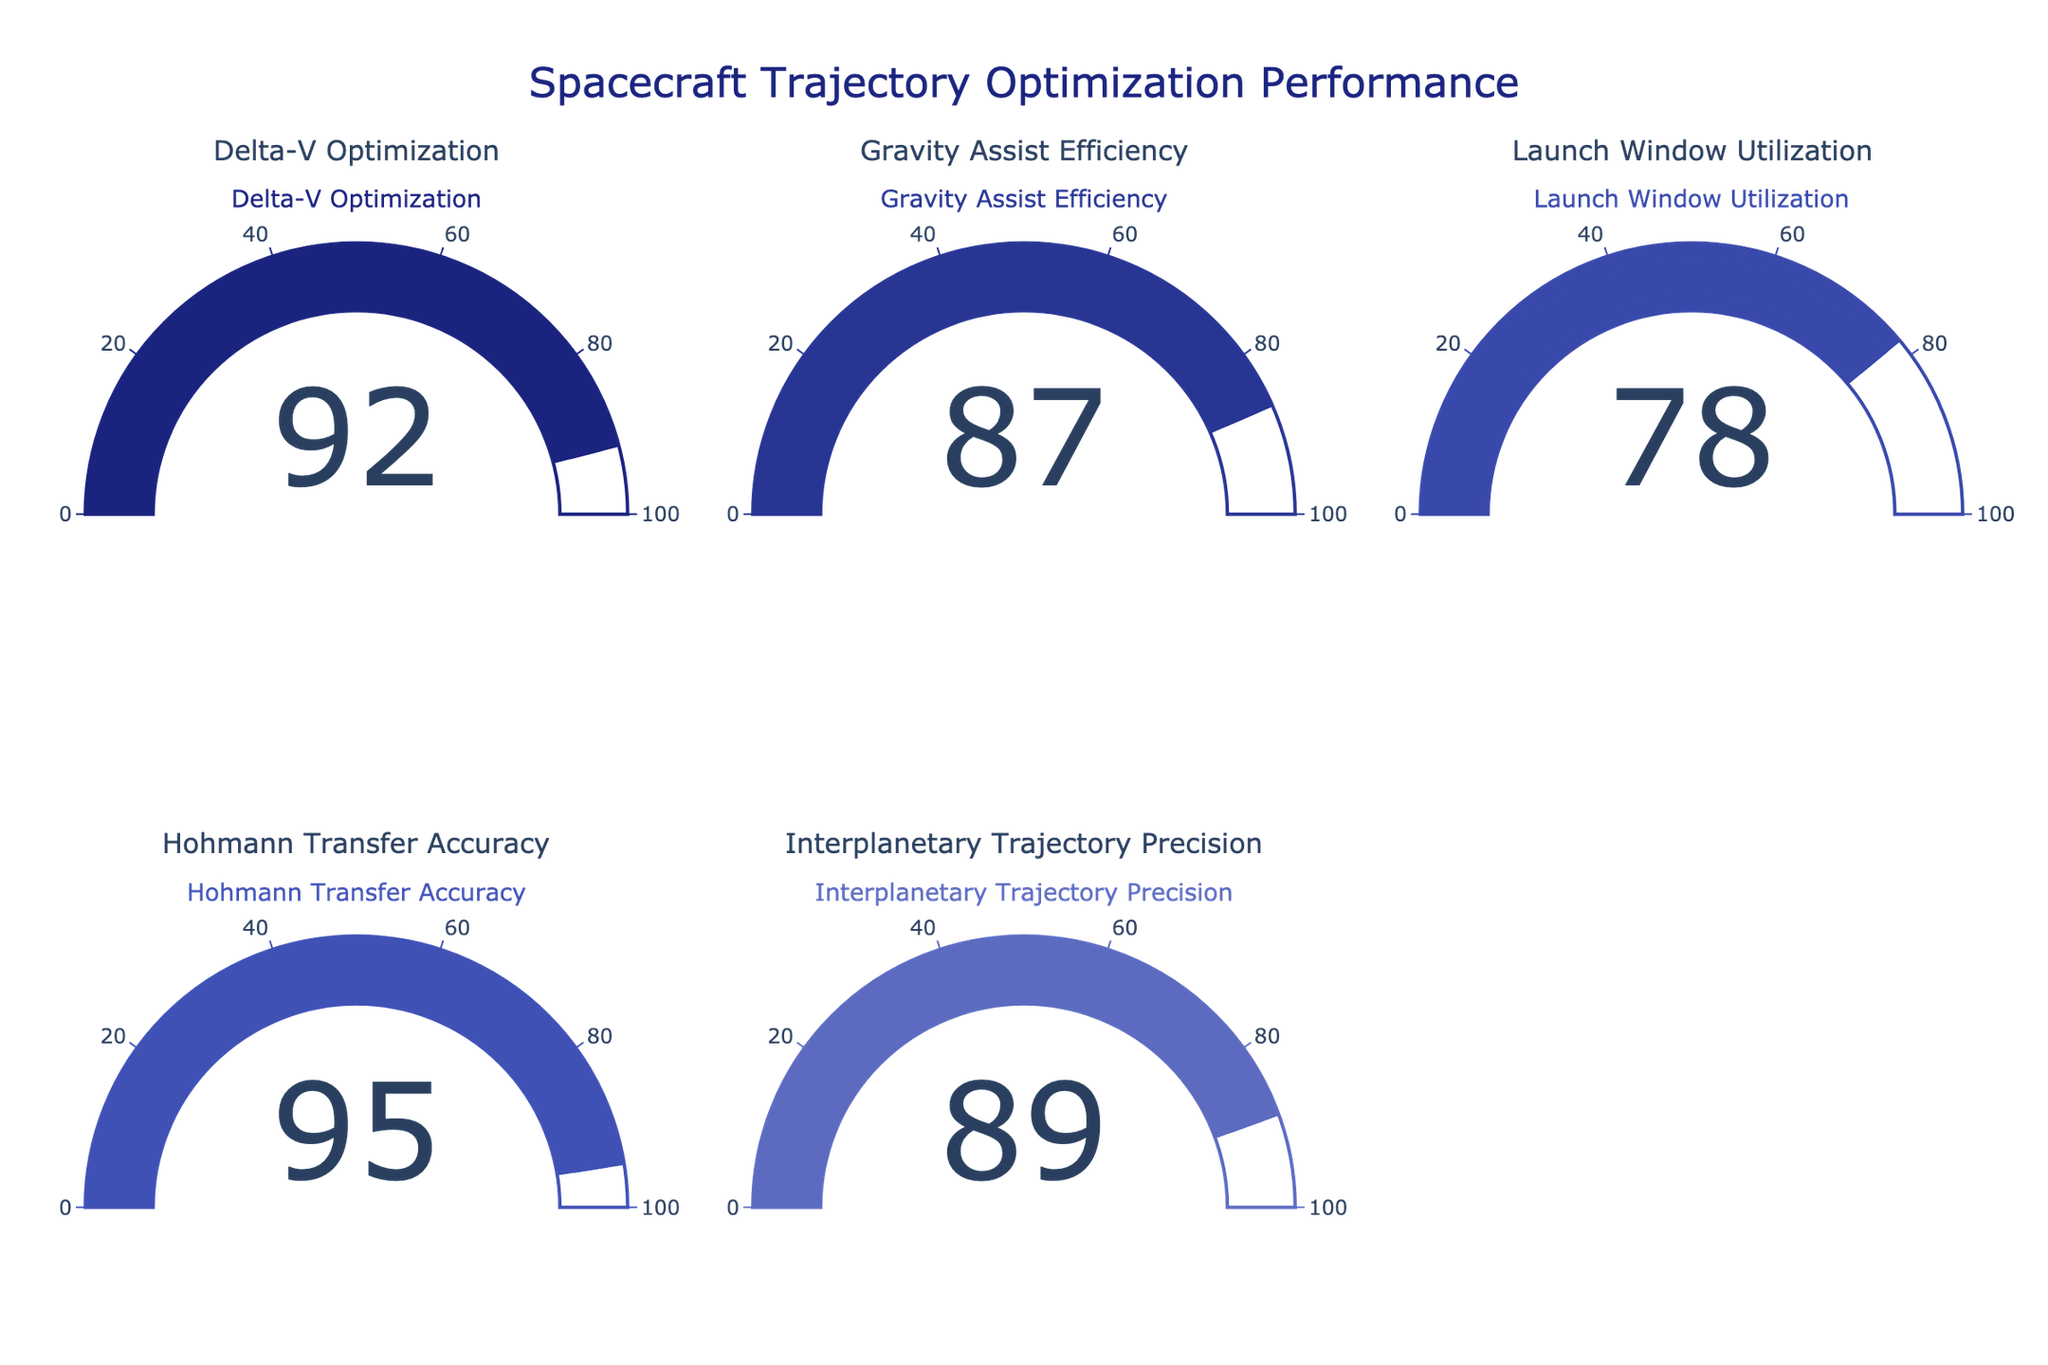Which mission has the highest performance? Identify the gauge with the highest value displayed. The "Hohmann Transfer Accuracy" shows a performance value of 95, which is the highest.
Answer: Hohmann Transfer Accuracy What is the title of the figure? Look at the central or top part of the figure to find the title. The title reads "Spacecraft Trajectory Optimization Performance."
Answer: Spacecraft Trajectory Optimization Performance How many missions are depicted in the figure? Count the number of unique gauges. There are 5 gauges, each corresponding to a different mission.
Answer: 5 Which mission has the lowest performance? Identify the gauge with the smallest value displayed. The "Launch Window Utilization" shows the lowest value at 78.
Answer: Launch Window Utilization What is the combined performance value of "Delta-V Optimization" and "Gravity Assist Efficiency"? Sum the values of these two missions. "Delta-V Optimization" is 92 and "Gravity Assist Efficiency" is 87. Their sum is 92 + 87 = 179.
Answer: 179 How much higher is the performance of "Hohmann Transfer Accuracy" compared to "Interplanetary Trajectory Precision"? Subtract the value of "Interplanetary Trajectory Precision" from "Hohmann Transfer Accuracy." Hohmann Transfer Accuracy is 95, and Interplanetary Trajectory Precision is 89. So, 95 - 89 = 6.
Answer: 6 Which missions have a performance value greater than 85? Identify the gauges with values higher than 85. These are "Delta-V Optimization" (92), "Gravity Assist Efficiency" (87), "Hohmann Transfer Accuracy" (95), and "Interplanetary Trajectory Precision" (89).
Answer: Delta-V Optimization, Gravity Assist Efficiency, Hohmann Transfer Accuracy, Interplanetary Trajectory Precision What is the average performance value of all the missions? Add all the performance values and divide by the number of missions. The values are 92, 87, 78, 95, and 89. Their sum is 92 + 87 + 78 + 95 + 89 = 441. Dividing by 5, the average is 441 / 5 = 88.2.
Answer: 88.2 What is the color of the gauge bar for "Interplanetary Trajectory Precision"? Look at the color of the "Interplanetary Trajectory Precision" gauge. It is colored with a shade of blue consistent with the custom color scale and corresponds to the color #5c6bc0.
Answer: Blue What is the difference between the highest and lowest performance values? Subtract the lowest performance value from the highest one. The highest is 95 ("Hohmann Transfer Accuracy"), and the lowest is 78 ("Launch Window Utilization"). So, 95 - 78 = 17.
Answer: 17 